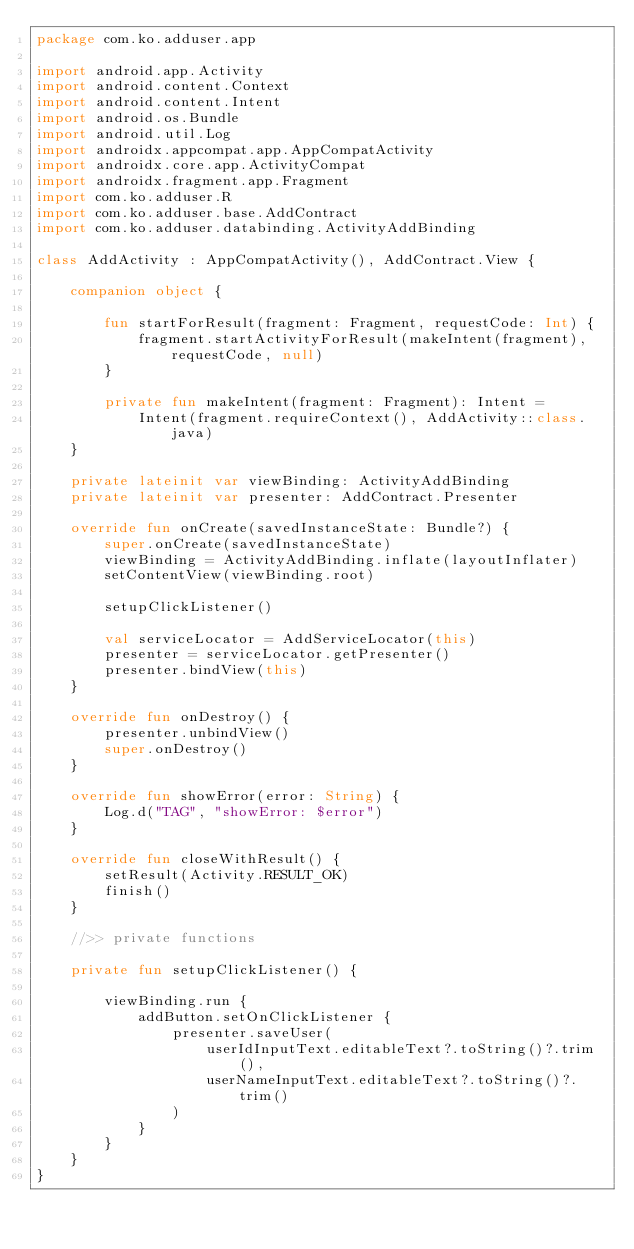<code> <loc_0><loc_0><loc_500><loc_500><_Kotlin_>package com.ko.adduser.app

import android.app.Activity
import android.content.Context
import android.content.Intent
import android.os.Bundle
import android.util.Log
import androidx.appcompat.app.AppCompatActivity
import androidx.core.app.ActivityCompat
import androidx.fragment.app.Fragment
import com.ko.adduser.R
import com.ko.adduser.base.AddContract
import com.ko.adduser.databinding.ActivityAddBinding

class AddActivity : AppCompatActivity(), AddContract.View {

    companion object {

        fun startForResult(fragment: Fragment, requestCode: Int) {
            fragment.startActivityForResult(makeIntent(fragment), requestCode, null)
        }

        private fun makeIntent(fragment: Fragment): Intent =
            Intent(fragment.requireContext(), AddActivity::class.java)
    }

    private lateinit var viewBinding: ActivityAddBinding
    private lateinit var presenter: AddContract.Presenter

    override fun onCreate(savedInstanceState: Bundle?) {
        super.onCreate(savedInstanceState)
        viewBinding = ActivityAddBinding.inflate(layoutInflater)
        setContentView(viewBinding.root)

        setupClickListener()

        val serviceLocator = AddServiceLocator(this)
        presenter = serviceLocator.getPresenter()
        presenter.bindView(this)
    }

    override fun onDestroy() {
        presenter.unbindView()
        super.onDestroy()
    }

    override fun showError(error: String) {
        Log.d("TAG", "showError: $error")
    }

    override fun closeWithResult() {
        setResult(Activity.RESULT_OK)
        finish()
    }

    //>> private functions

    private fun setupClickListener() {

        viewBinding.run {
            addButton.setOnClickListener {
                presenter.saveUser(
                    userIdInputText.editableText?.toString()?.trim(),
                    userNameInputText.editableText?.toString()?.trim()
                )
            }
        }
    }
}
</code> 